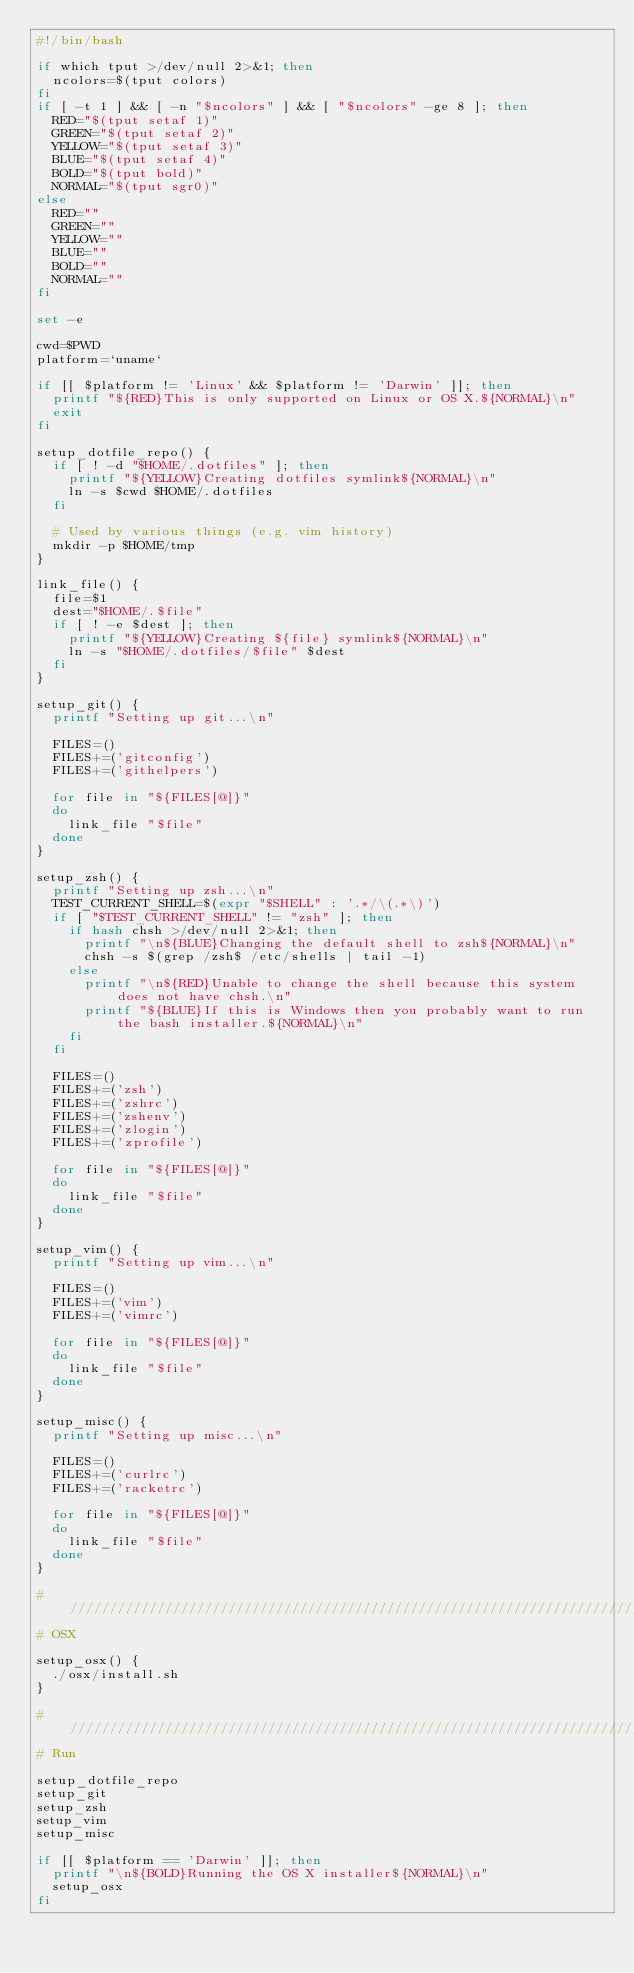<code> <loc_0><loc_0><loc_500><loc_500><_Bash_>#!/bin/bash

if which tput >/dev/null 2>&1; then
  ncolors=$(tput colors)
fi
if [ -t 1 ] && [ -n "$ncolors" ] && [ "$ncolors" -ge 8 ]; then
  RED="$(tput setaf 1)"
  GREEN="$(tput setaf 2)"
  YELLOW="$(tput setaf 3)"
  BLUE="$(tput setaf 4)"
  BOLD="$(tput bold)"
  NORMAL="$(tput sgr0)"
else
  RED=""
  GREEN=""
  YELLOW=""
  BLUE=""
  BOLD=""
  NORMAL=""
fi

set -e

cwd=$PWD
platform=`uname`

if [[ $platform != 'Linux' && $platform != 'Darwin' ]]; then
  printf "${RED}This is only supported on Linux or OS X.${NORMAL}\n"
  exit
fi

setup_dotfile_repo() {
  if [ ! -d "$HOME/.dotfiles" ]; then
    printf "${YELLOW}Creating dotfiles symlink${NORMAL}\n"
    ln -s $cwd $HOME/.dotfiles
  fi

  # Used by various things (e.g. vim history)
  mkdir -p $HOME/tmp
}

link_file() {
  file=$1
  dest="$HOME/.$file"
  if [ ! -e $dest ]; then
    printf "${YELLOW}Creating ${file} symlink${NORMAL}\n"
    ln -s "$HOME/.dotfiles/$file" $dest
  fi
}

setup_git() {
  printf "Setting up git...\n"

  FILES=()
  FILES+=('gitconfig')
  FILES+=('githelpers')

  for file in "${FILES[@]}"
  do
    link_file "$file"
  done
}

setup_zsh() {
  printf "Setting up zsh...\n"
  TEST_CURRENT_SHELL=$(expr "$SHELL" : '.*/\(.*\)')
  if [ "$TEST_CURRENT_SHELL" != "zsh" ]; then
    if hash chsh >/dev/null 2>&1; then
      printf "\n${BLUE}Changing the default shell to zsh${NORMAL}\n"
      chsh -s $(grep /zsh$ /etc/shells | tail -1)
    else
      printf "\n${RED}Unable to change the shell because this system does not have chsh.\n"
      printf "${BLUE}If this is Windows then you probably want to run the bash installer.${NORMAL}\n"
    fi
  fi

  FILES=()
  FILES+=('zsh')
  FILES+=('zshrc')
  FILES+=('zshenv')
  FILES+=('zlogin')
  FILES+=('zprofile')

  for file in "${FILES[@]}"
  do
    link_file "$file"
  done
}

setup_vim() {
  printf "Setting up vim...\n"

  FILES=()
  FILES+=('vim')
  FILES+=('vimrc')

  for file in "${FILES[@]}"
  do
    link_file "$file"
  done
}

setup_misc() {
  printf "Setting up misc...\n"

  FILES=()
  FILES+=('curlrc')
  FILES+=('racketrc')

  for file in "${FILES[@]}"
  do
    link_file "$file"
  done
}

# ////////////////////////////////////////////////////////////////////////////////////////
# OSX

setup_osx() {
  ./osx/install.sh
}

# ////////////////////////////////////////////////////////////////////////////////////////
# Run

setup_dotfile_repo
setup_git
setup_zsh
setup_vim
setup_misc

if [[ $platform == 'Darwin' ]]; then
  printf "\n${BOLD}Running the OS X installer${NORMAL}\n"
  setup_osx
fi
</code> 